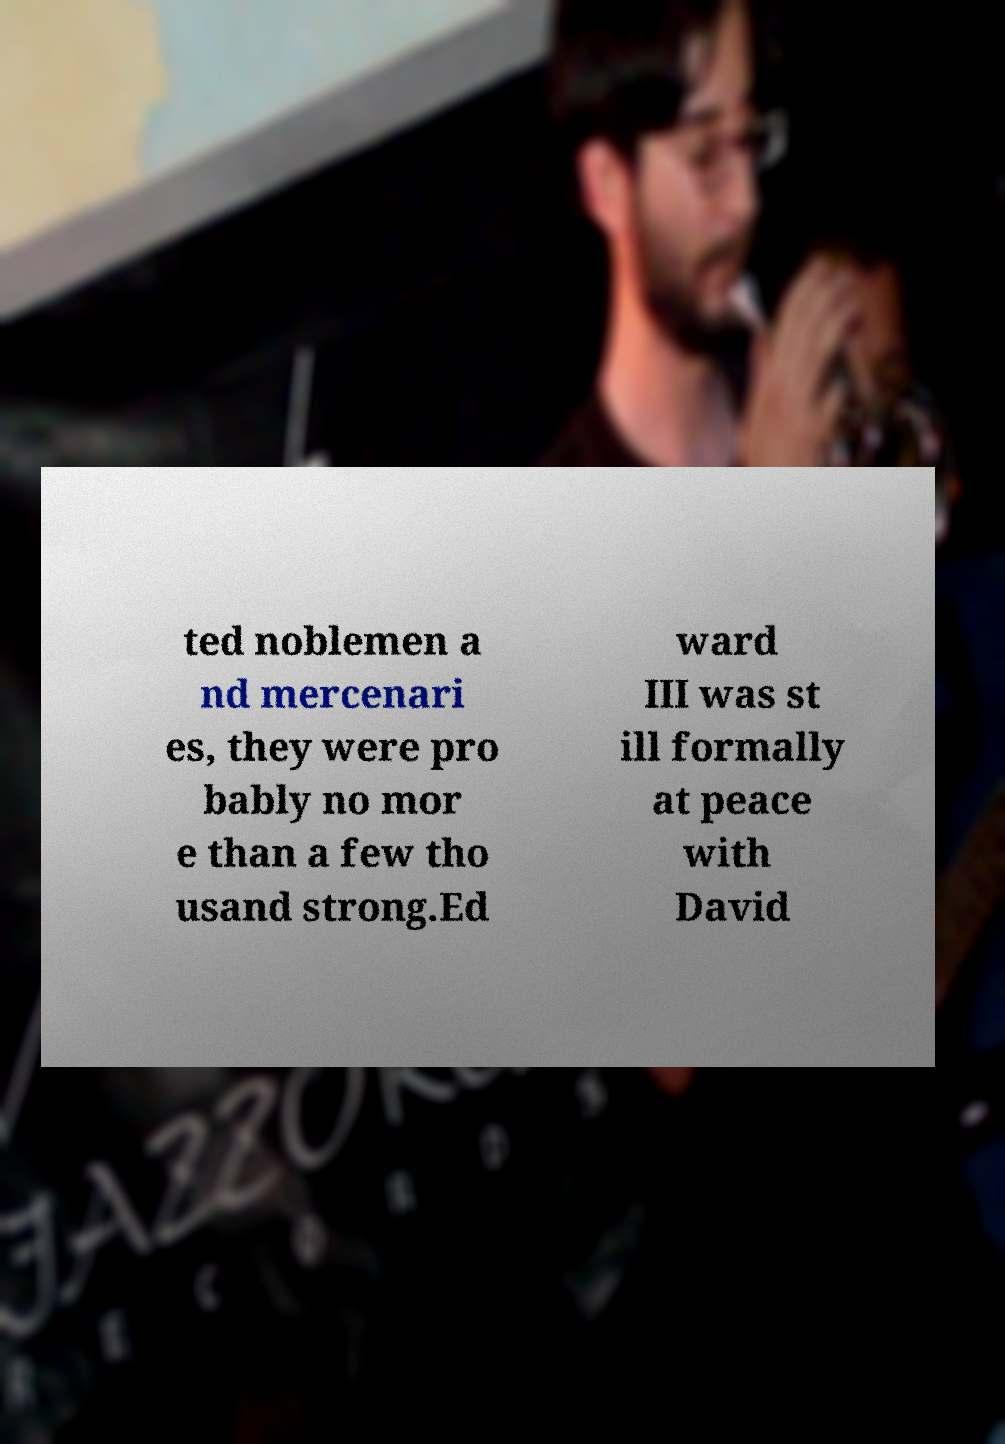Please identify and transcribe the text found in this image. ted noblemen a nd mercenari es, they were pro bably no mor e than a few tho usand strong.Ed ward III was st ill formally at peace with David 